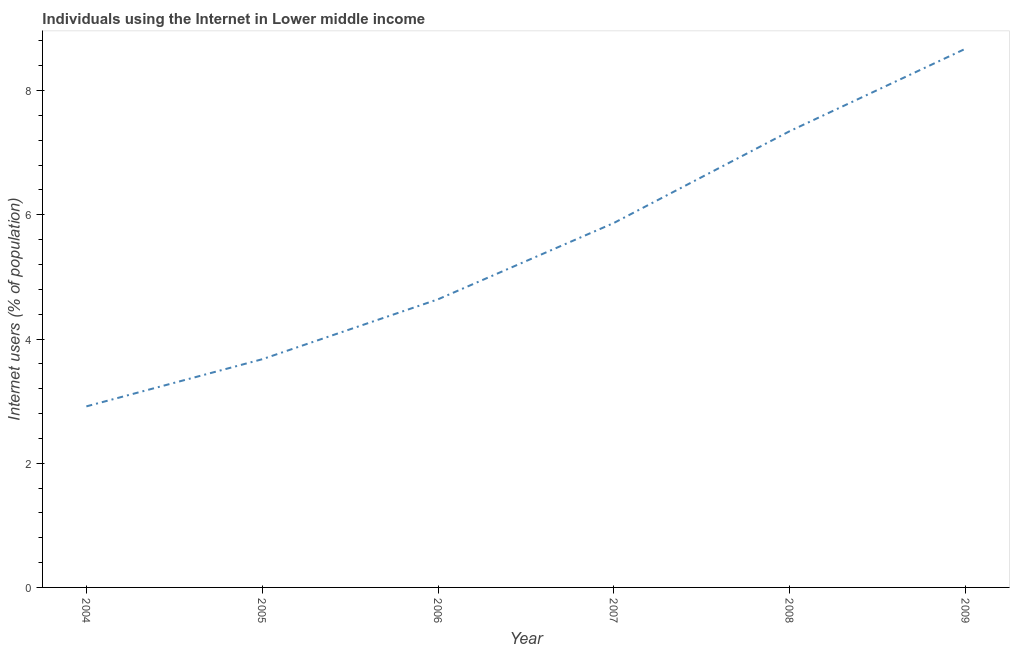What is the number of internet users in 2006?
Offer a very short reply. 4.64. Across all years, what is the maximum number of internet users?
Offer a terse response. 8.67. Across all years, what is the minimum number of internet users?
Offer a very short reply. 2.92. In which year was the number of internet users minimum?
Make the answer very short. 2004. What is the sum of the number of internet users?
Provide a succinct answer. 33.12. What is the difference between the number of internet users in 2004 and 2007?
Your answer should be compact. -2.95. What is the average number of internet users per year?
Give a very brief answer. 5.52. What is the median number of internet users?
Provide a succinct answer. 5.25. Do a majority of the years between 2009 and 2006 (inclusive) have number of internet users greater than 7.2 %?
Make the answer very short. Yes. What is the ratio of the number of internet users in 2004 to that in 2008?
Your answer should be very brief. 0.4. What is the difference between the highest and the second highest number of internet users?
Offer a very short reply. 1.33. Is the sum of the number of internet users in 2005 and 2006 greater than the maximum number of internet users across all years?
Offer a very short reply. No. What is the difference between the highest and the lowest number of internet users?
Offer a very short reply. 5.76. How many lines are there?
Make the answer very short. 1. How many years are there in the graph?
Provide a succinct answer. 6. What is the difference between two consecutive major ticks on the Y-axis?
Offer a very short reply. 2. What is the title of the graph?
Ensure brevity in your answer.  Individuals using the Internet in Lower middle income. What is the label or title of the Y-axis?
Give a very brief answer. Internet users (% of population). What is the Internet users (% of population) in 2004?
Provide a succinct answer. 2.92. What is the Internet users (% of population) of 2005?
Your answer should be compact. 3.67. What is the Internet users (% of population) in 2006?
Provide a succinct answer. 4.64. What is the Internet users (% of population) of 2007?
Ensure brevity in your answer.  5.87. What is the Internet users (% of population) in 2008?
Provide a short and direct response. 7.35. What is the Internet users (% of population) in 2009?
Make the answer very short. 8.67. What is the difference between the Internet users (% of population) in 2004 and 2005?
Give a very brief answer. -0.76. What is the difference between the Internet users (% of population) in 2004 and 2006?
Offer a terse response. -1.72. What is the difference between the Internet users (% of population) in 2004 and 2007?
Your answer should be very brief. -2.95. What is the difference between the Internet users (% of population) in 2004 and 2008?
Give a very brief answer. -4.43. What is the difference between the Internet users (% of population) in 2004 and 2009?
Provide a short and direct response. -5.76. What is the difference between the Internet users (% of population) in 2005 and 2006?
Offer a very short reply. -0.96. What is the difference between the Internet users (% of population) in 2005 and 2007?
Give a very brief answer. -2.19. What is the difference between the Internet users (% of population) in 2005 and 2008?
Ensure brevity in your answer.  -3.67. What is the difference between the Internet users (% of population) in 2005 and 2009?
Offer a very short reply. -5. What is the difference between the Internet users (% of population) in 2006 and 2007?
Keep it short and to the point. -1.23. What is the difference between the Internet users (% of population) in 2006 and 2008?
Offer a terse response. -2.71. What is the difference between the Internet users (% of population) in 2006 and 2009?
Ensure brevity in your answer.  -4.04. What is the difference between the Internet users (% of population) in 2007 and 2008?
Your answer should be very brief. -1.48. What is the difference between the Internet users (% of population) in 2007 and 2009?
Offer a terse response. -2.81. What is the difference between the Internet users (% of population) in 2008 and 2009?
Your answer should be very brief. -1.33. What is the ratio of the Internet users (% of population) in 2004 to that in 2005?
Your response must be concise. 0.79. What is the ratio of the Internet users (% of population) in 2004 to that in 2006?
Your answer should be compact. 0.63. What is the ratio of the Internet users (% of population) in 2004 to that in 2007?
Offer a terse response. 0.5. What is the ratio of the Internet users (% of population) in 2004 to that in 2008?
Your answer should be compact. 0.4. What is the ratio of the Internet users (% of population) in 2004 to that in 2009?
Your response must be concise. 0.34. What is the ratio of the Internet users (% of population) in 2005 to that in 2006?
Your response must be concise. 0.79. What is the ratio of the Internet users (% of population) in 2005 to that in 2007?
Keep it short and to the point. 0.63. What is the ratio of the Internet users (% of population) in 2005 to that in 2008?
Offer a very short reply. 0.5. What is the ratio of the Internet users (% of population) in 2005 to that in 2009?
Keep it short and to the point. 0.42. What is the ratio of the Internet users (% of population) in 2006 to that in 2007?
Your answer should be compact. 0.79. What is the ratio of the Internet users (% of population) in 2006 to that in 2008?
Your response must be concise. 0.63. What is the ratio of the Internet users (% of population) in 2006 to that in 2009?
Your answer should be compact. 0.54. What is the ratio of the Internet users (% of population) in 2007 to that in 2008?
Offer a very short reply. 0.8. What is the ratio of the Internet users (% of population) in 2007 to that in 2009?
Offer a terse response. 0.68. What is the ratio of the Internet users (% of population) in 2008 to that in 2009?
Keep it short and to the point. 0.85. 